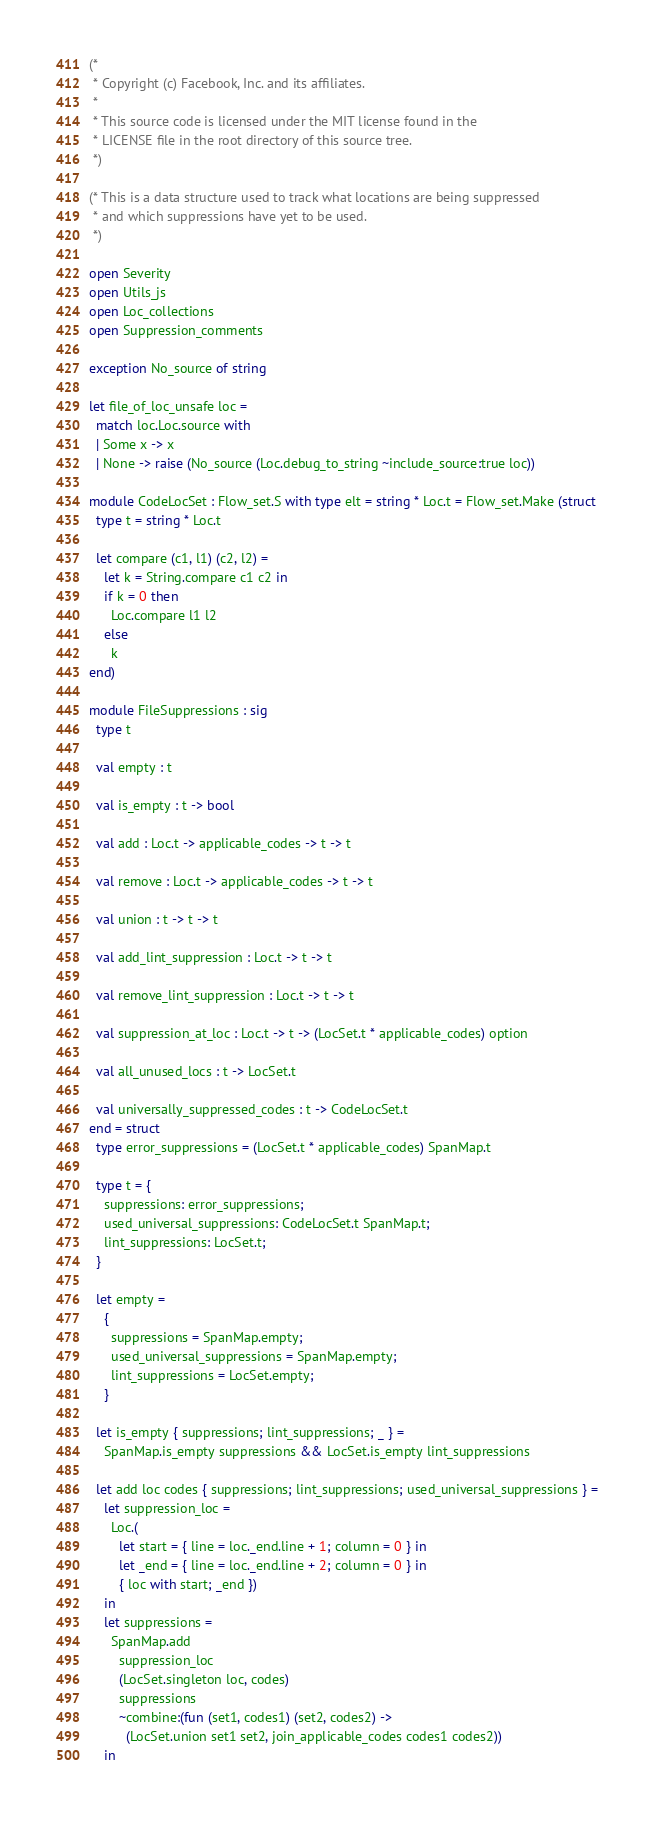<code> <loc_0><loc_0><loc_500><loc_500><_OCaml_>(*
 * Copyright (c) Facebook, Inc. and its affiliates.
 *
 * This source code is licensed under the MIT license found in the
 * LICENSE file in the root directory of this source tree.
 *)

(* This is a data structure used to track what locations are being suppressed
 * and which suppressions have yet to be used.
 *)

open Severity
open Utils_js
open Loc_collections
open Suppression_comments

exception No_source of string

let file_of_loc_unsafe loc =
  match loc.Loc.source with
  | Some x -> x
  | None -> raise (No_source (Loc.debug_to_string ~include_source:true loc))

module CodeLocSet : Flow_set.S with type elt = string * Loc.t = Flow_set.Make (struct
  type t = string * Loc.t

  let compare (c1, l1) (c2, l2) =
    let k = String.compare c1 c2 in
    if k = 0 then
      Loc.compare l1 l2
    else
      k
end)

module FileSuppressions : sig
  type t

  val empty : t

  val is_empty : t -> bool

  val add : Loc.t -> applicable_codes -> t -> t

  val remove : Loc.t -> applicable_codes -> t -> t

  val union : t -> t -> t

  val add_lint_suppression : Loc.t -> t -> t

  val remove_lint_suppression : Loc.t -> t -> t

  val suppression_at_loc : Loc.t -> t -> (LocSet.t * applicable_codes) option

  val all_unused_locs : t -> LocSet.t

  val universally_suppressed_codes : t -> CodeLocSet.t
end = struct
  type error_suppressions = (LocSet.t * applicable_codes) SpanMap.t

  type t = {
    suppressions: error_suppressions;
    used_universal_suppressions: CodeLocSet.t SpanMap.t;
    lint_suppressions: LocSet.t;
  }

  let empty =
    {
      suppressions = SpanMap.empty;
      used_universal_suppressions = SpanMap.empty;
      lint_suppressions = LocSet.empty;
    }

  let is_empty { suppressions; lint_suppressions; _ } =
    SpanMap.is_empty suppressions && LocSet.is_empty lint_suppressions

  let add loc codes { suppressions; lint_suppressions; used_universal_suppressions } =
    let suppression_loc =
      Loc.(
        let start = { line = loc._end.line + 1; column = 0 } in
        let _end = { line = loc._end.line + 2; column = 0 } in
        { loc with start; _end })
    in
    let suppressions =
      SpanMap.add
        suppression_loc
        (LocSet.singleton loc, codes)
        suppressions
        ~combine:(fun (set1, codes1) (set2, codes2) ->
          (LocSet.union set1 set2, join_applicable_codes codes1 codes2))
    in</code> 